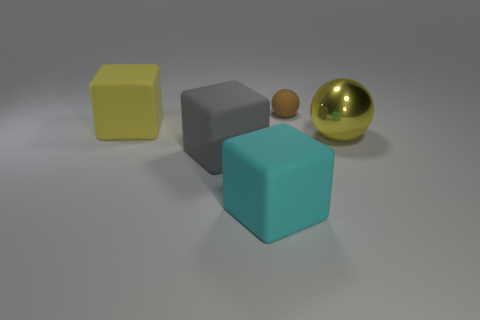Add 2 gray shiny cubes. How many objects exist? 7 Subtract all gray blocks. How many blocks are left? 2 Subtract 1 spheres. How many spheres are left? 1 Subtract all blocks. How many objects are left? 2 Subtract all yellow blocks. Subtract all cyan spheres. How many blocks are left? 2 Subtract all brown matte balls. Subtract all yellow rubber objects. How many objects are left? 3 Add 5 cyan matte blocks. How many cyan matte blocks are left? 6 Add 4 balls. How many balls exist? 6 Subtract 1 cyan cubes. How many objects are left? 4 